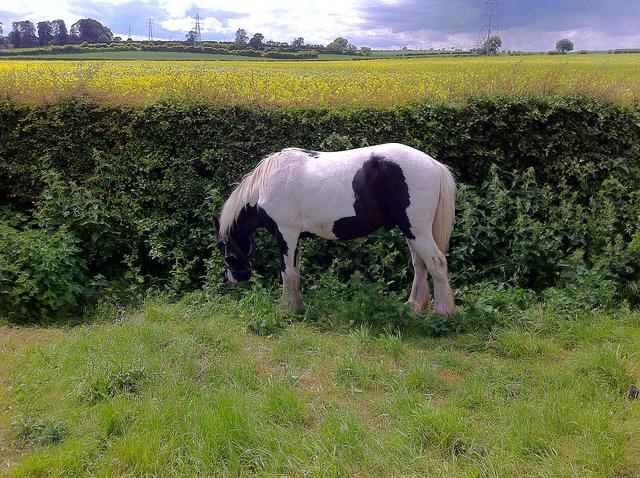What is the horse eating?
Answer briefly. Grass. What is the horse feeding on?
Concise answer only. Grass. What color are the horse's spots?
Write a very short answer. Black. 